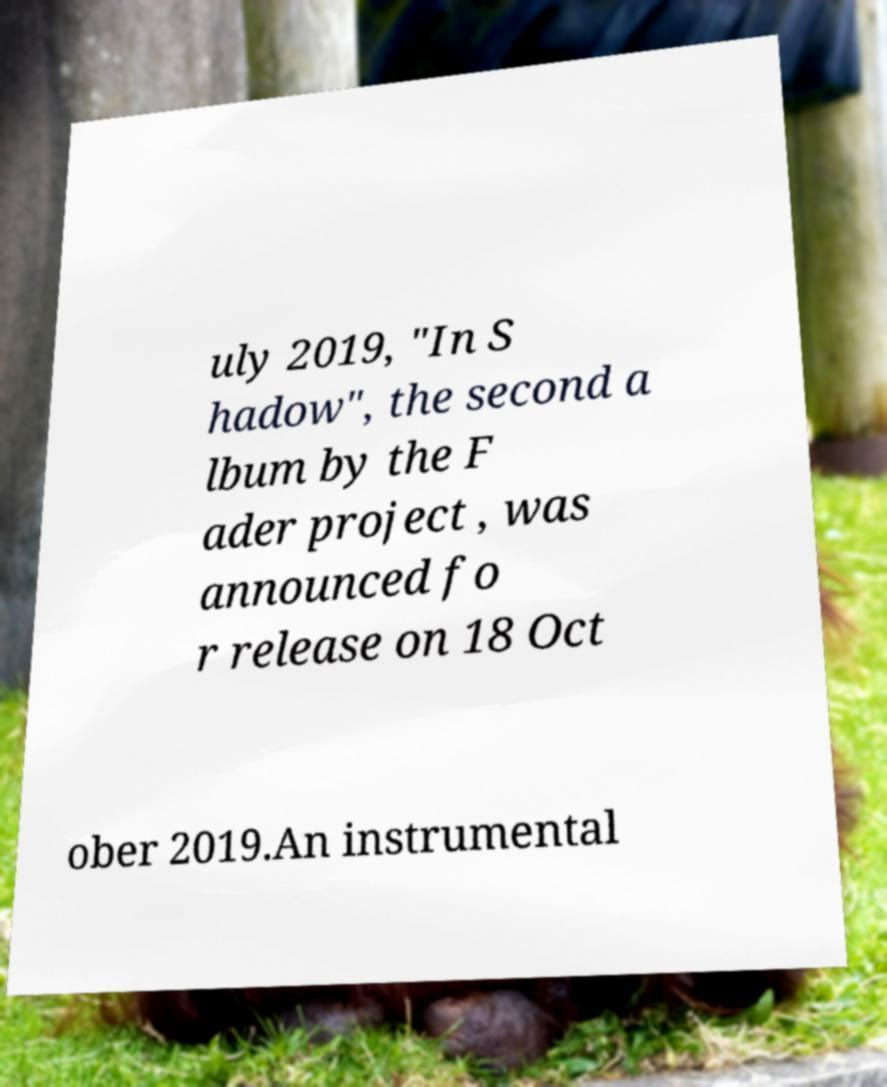Please read and relay the text visible in this image. What does it say? uly 2019, "In S hadow", the second a lbum by the F ader project , was announced fo r release on 18 Oct ober 2019.An instrumental 